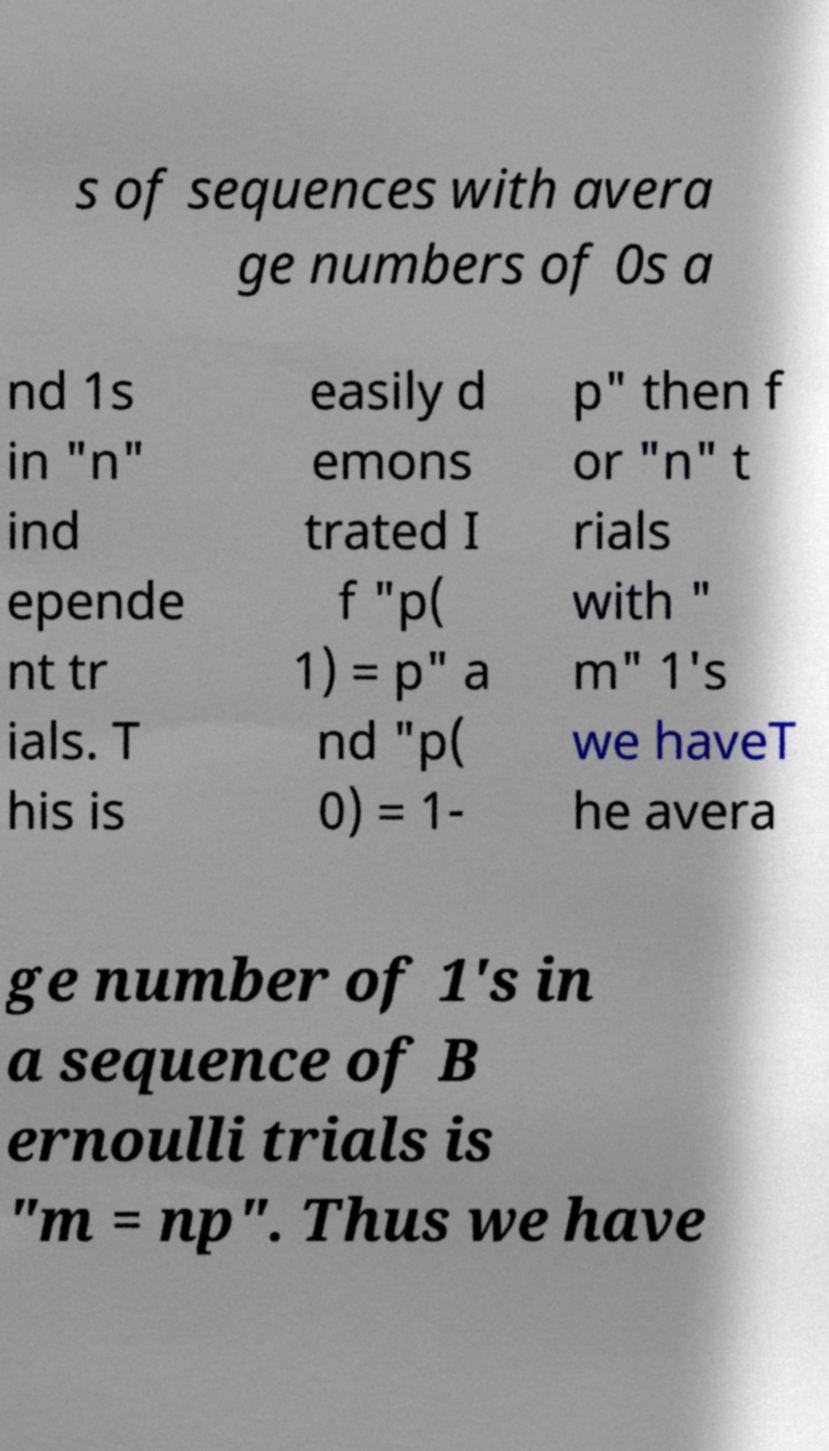Could you assist in decoding the text presented in this image and type it out clearly? s of sequences with avera ge numbers of 0s a nd 1s in "n" ind epende nt tr ials. T his is easily d emons trated I f "p( 1) = p" a nd "p( 0) = 1- p" then f or "n" t rials with " m" 1's we haveT he avera ge number of 1's in a sequence of B ernoulli trials is "m = np". Thus we have 